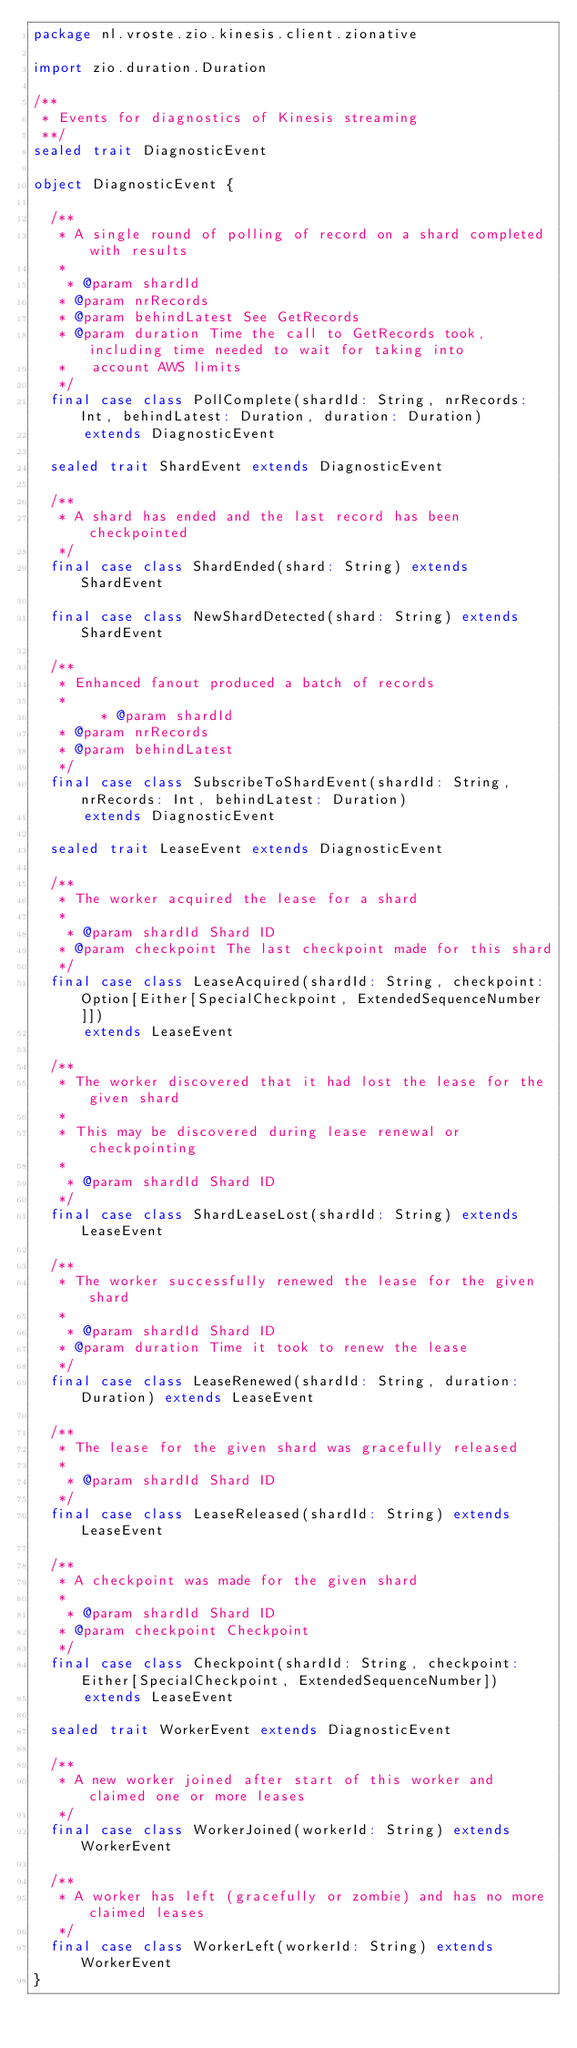Convert code to text. <code><loc_0><loc_0><loc_500><loc_500><_Scala_>package nl.vroste.zio.kinesis.client.zionative

import zio.duration.Duration

/**
 * Events for diagnostics of Kinesis streaming
 **/
sealed trait DiagnosticEvent

object DiagnosticEvent {

  /**
   * A single round of polling of record on a shard completed with results
   *
    * @param shardId
   * @param nrRecords
   * @param behindLatest See GetRecords
   * @param duration Time the call to GetRecords took, including time needed to wait for taking into
   *   account AWS limits
   */
  final case class PollComplete(shardId: String, nrRecords: Int, behindLatest: Duration, duration: Duration)
      extends DiagnosticEvent

  sealed trait ShardEvent extends DiagnosticEvent

  /**
   * A shard has ended and the last record has been checkpointed
   */
  final case class ShardEnded(shard: String) extends ShardEvent

  final case class NewShardDetected(shard: String) extends ShardEvent

  /**
   * Enhanced fanout produced a batch of records
   *
        * @param shardId
   * @param nrRecords
   * @param behindLatest
   */
  final case class SubscribeToShardEvent(shardId: String, nrRecords: Int, behindLatest: Duration)
      extends DiagnosticEvent

  sealed trait LeaseEvent extends DiagnosticEvent

  /**
   * The worker acquired the lease for a shard
   *
    * @param shardId Shard ID
   * @param checkpoint The last checkpoint made for this shard
   */
  final case class LeaseAcquired(shardId: String, checkpoint: Option[Either[SpecialCheckpoint, ExtendedSequenceNumber]])
      extends LeaseEvent

  /**
   * The worker discovered that it had lost the lease for the given shard
   *
   * This may be discovered during lease renewal or checkpointing
   *
    * @param shardId Shard ID
   */
  final case class ShardLeaseLost(shardId: String) extends LeaseEvent

  /**
   * The worker successfully renewed the lease for the given shard
   *
    * @param shardId Shard ID
   * @param duration Time it took to renew the lease
   */
  final case class LeaseRenewed(shardId: String, duration: Duration) extends LeaseEvent

  /**
   * The lease for the given shard was gracefully released
   *
    * @param shardId Shard ID
   */
  final case class LeaseReleased(shardId: String) extends LeaseEvent

  /**
   * A checkpoint was made for the given shard
   *
    * @param shardId Shard ID
   * @param checkpoint Checkpoint
   */
  final case class Checkpoint(shardId: String, checkpoint: Either[SpecialCheckpoint, ExtendedSequenceNumber])
      extends LeaseEvent

  sealed trait WorkerEvent extends DiagnosticEvent

  /**
   * A new worker joined after start of this worker and claimed one or more leases
   */
  final case class WorkerJoined(workerId: String) extends WorkerEvent

  /**
   * A worker has left (gracefully or zombie) and has no more claimed leases
   */
  final case class WorkerLeft(workerId: String) extends WorkerEvent
}
</code> 